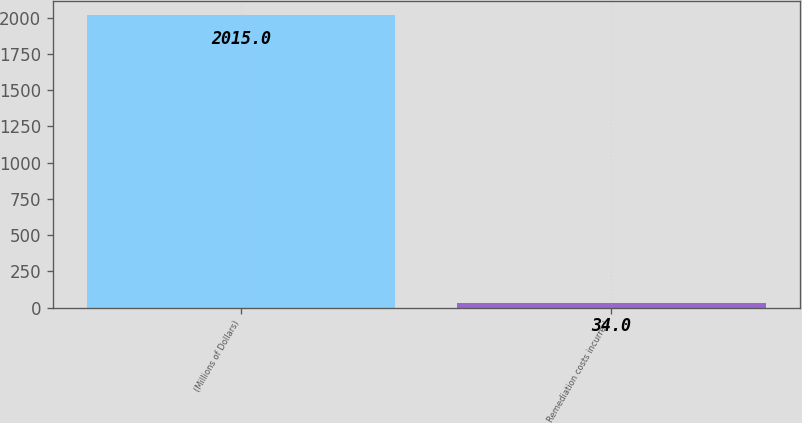<chart> <loc_0><loc_0><loc_500><loc_500><bar_chart><fcel>(Millions of Dollars)<fcel>Remediation costs incurred<nl><fcel>2015<fcel>34<nl></chart> 